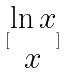Convert formula to latex. <formula><loc_0><loc_0><loc_500><loc_500>[ \begin{matrix} \ln x \\ x \end{matrix} ]</formula> 